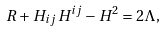Convert formula to latex. <formula><loc_0><loc_0><loc_500><loc_500>R + H _ { i j } H ^ { i j } - H ^ { 2 } = 2 \Lambda ,</formula> 